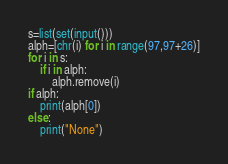Convert code to text. <code><loc_0><loc_0><loc_500><loc_500><_Python_>s=list(set(input()))
alph=[chr(i) for i in range(97,97+26)]
for i in s:
    if i in alph:
        alph.remove(i)
if alph:
    print(alph[0])
else:
    print("None")</code> 